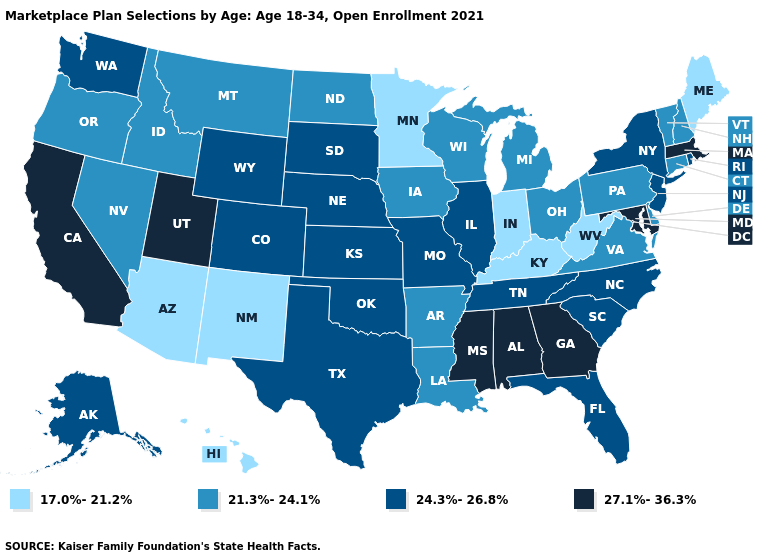Does Minnesota have the lowest value in the USA?
Concise answer only. Yes. What is the value of Wyoming?
Give a very brief answer. 24.3%-26.8%. What is the highest value in the USA?
Give a very brief answer. 27.1%-36.3%. Name the states that have a value in the range 27.1%-36.3%?
Short answer required. Alabama, California, Georgia, Maryland, Massachusetts, Mississippi, Utah. Which states have the highest value in the USA?
Give a very brief answer. Alabama, California, Georgia, Maryland, Massachusetts, Mississippi, Utah. What is the value of Alaska?
Short answer required. 24.3%-26.8%. What is the value of West Virginia?
Give a very brief answer. 17.0%-21.2%. What is the value of Nebraska?
Answer briefly. 24.3%-26.8%. What is the highest value in the MidWest ?
Answer briefly. 24.3%-26.8%. What is the value of Florida?
Keep it brief. 24.3%-26.8%. Does Montana have a higher value than Georgia?
Be succinct. No. Among the states that border Utah , which have the lowest value?
Short answer required. Arizona, New Mexico. Name the states that have a value in the range 17.0%-21.2%?
Give a very brief answer. Arizona, Hawaii, Indiana, Kentucky, Maine, Minnesota, New Mexico, West Virginia. What is the value of New York?
Be succinct. 24.3%-26.8%. Among the states that border New Mexico , which have the lowest value?
Answer briefly. Arizona. 